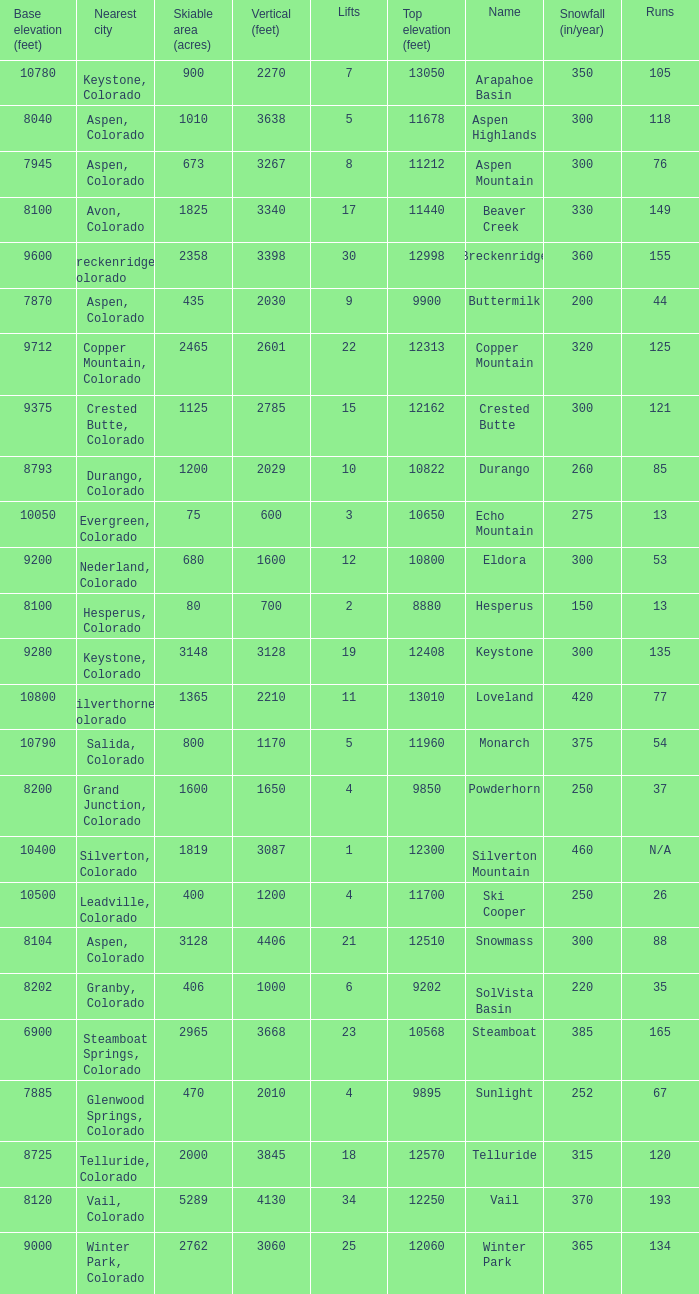If there are 30 lifts, what is the name of the ski resort? Breckenridge. 